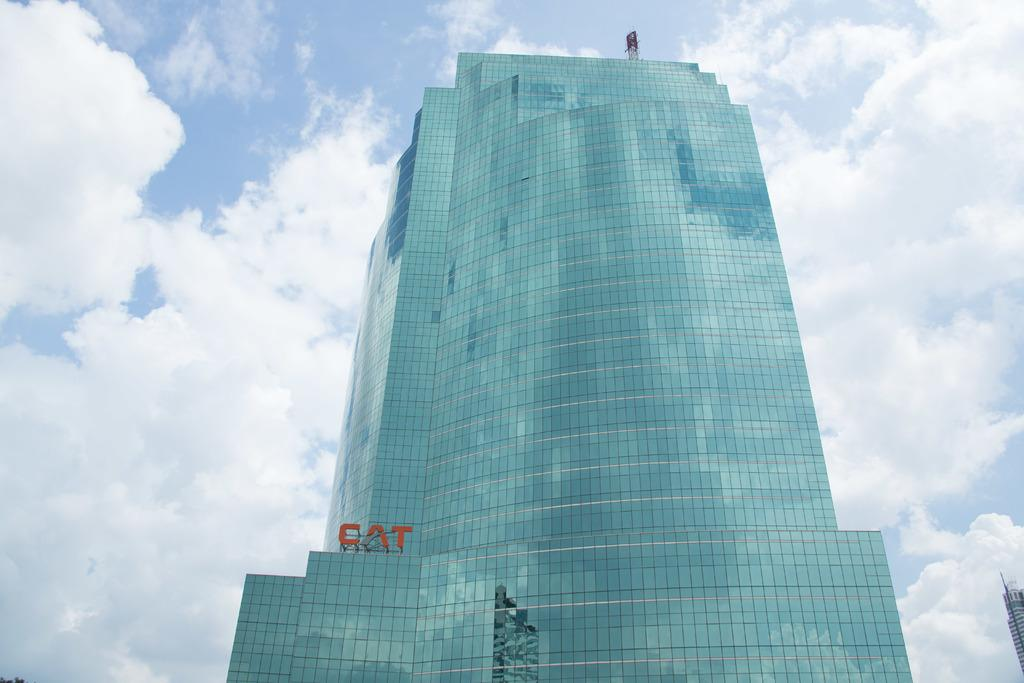<image>
Present a compact description of the photo's key features. The CAT sign is shown at the bottom left of this large building. 